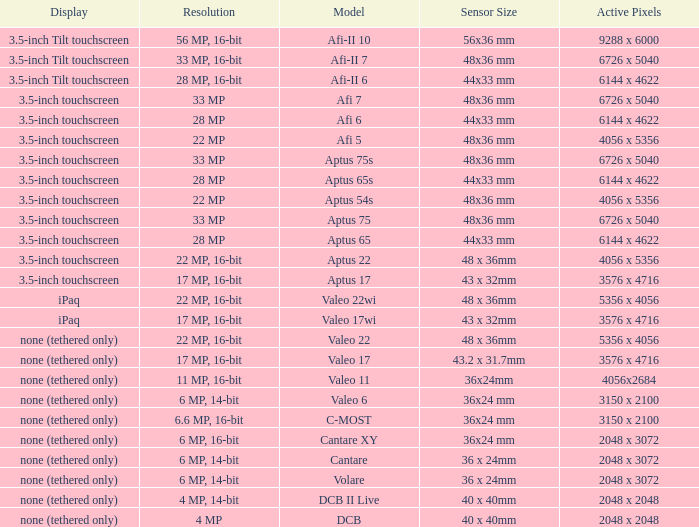What are the active pixels of the cantare model? 2048 x 3072. 